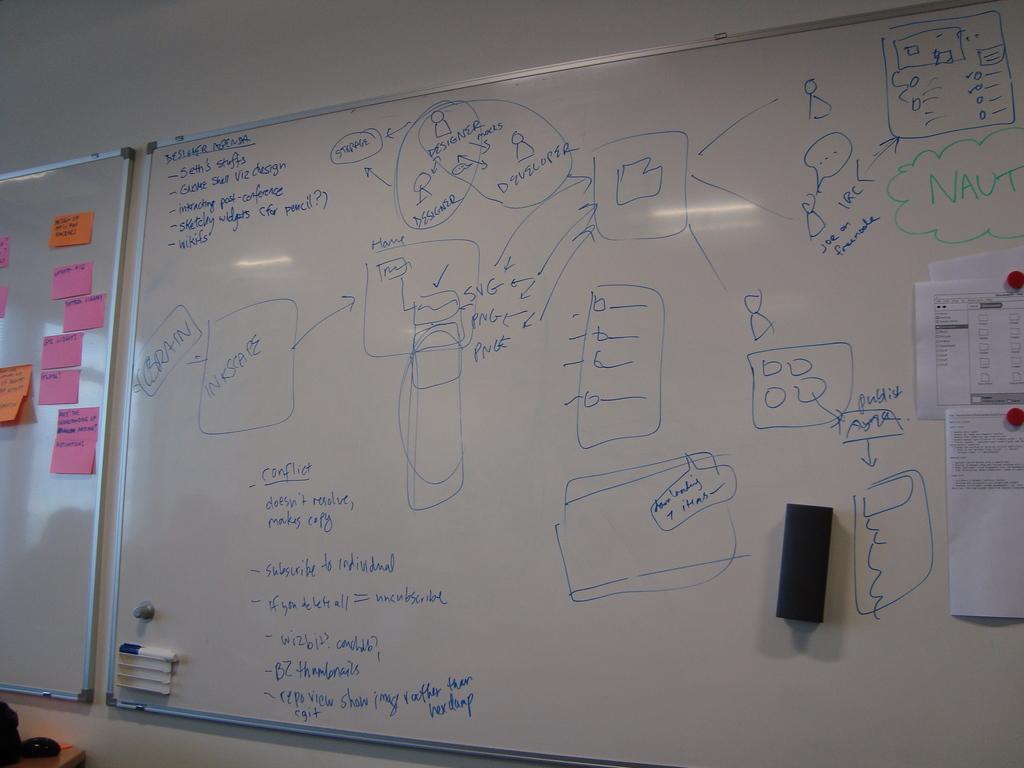What's the conflict?
Make the answer very short. Doesn't resolve, makes copy. What do the two designers point to at the top of the board?
Your answer should be compact. Storage. 